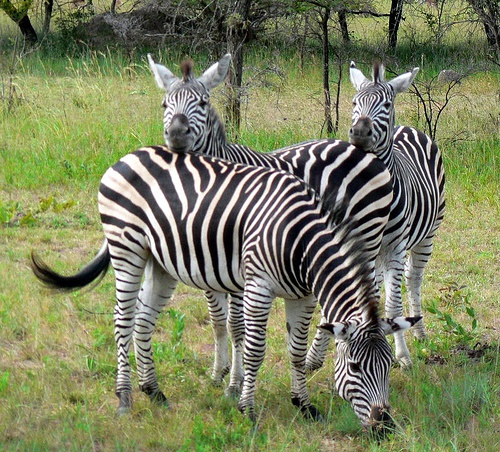Describe the objects in this image and their specific colors. I can see zebra in darkgreen, black, gray, lightgray, and darkgray tones, zebra in darkgreen, black, darkgray, gray, and lightgray tones, and zebra in darkgreen, darkgray, gray, black, and lightgray tones in this image. 